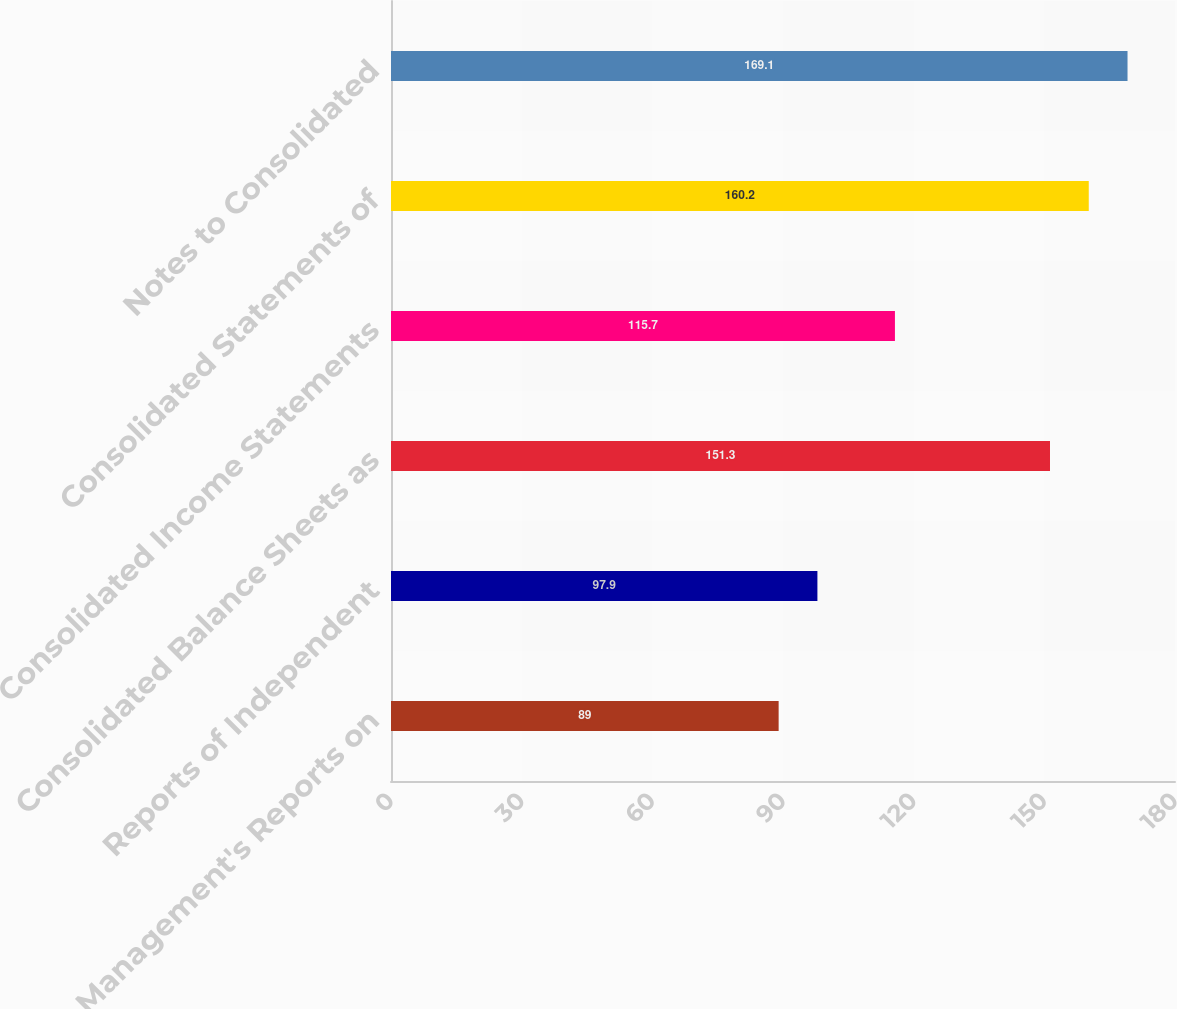<chart> <loc_0><loc_0><loc_500><loc_500><bar_chart><fcel>Management's Reports on<fcel>Reports of Independent<fcel>Consolidated Balance Sheets as<fcel>Consolidated Income Statements<fcel>Consolidated Statements of<fcel>Notes to Consolidated<nl><fcel>89<fcel>97.9<fcel>151.3<fcel>115.7<fcel>160.2<fcel>169.1<nl></chart> 